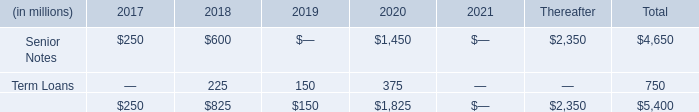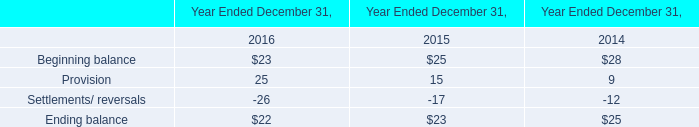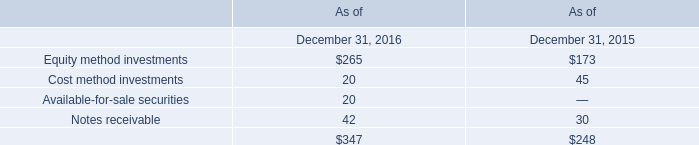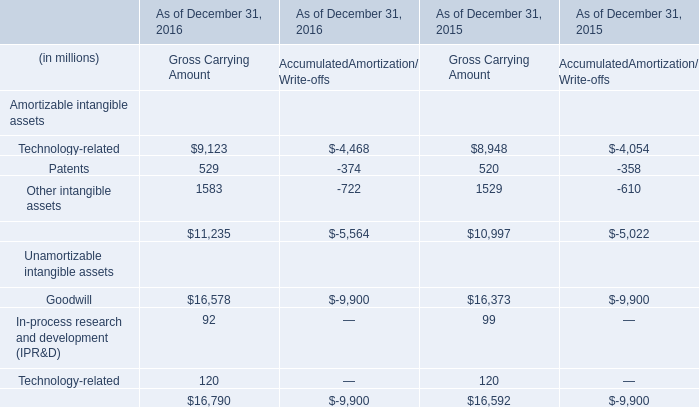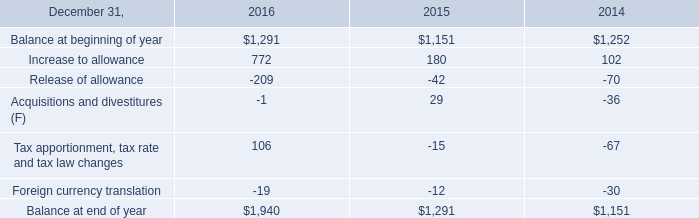What is the average amount of Senior Notes of Thereafter, and Balance at end of year of 2016 ? 
Computations: ((2350.0 + 1940.0) / 2)
Answer: 2145.0. 